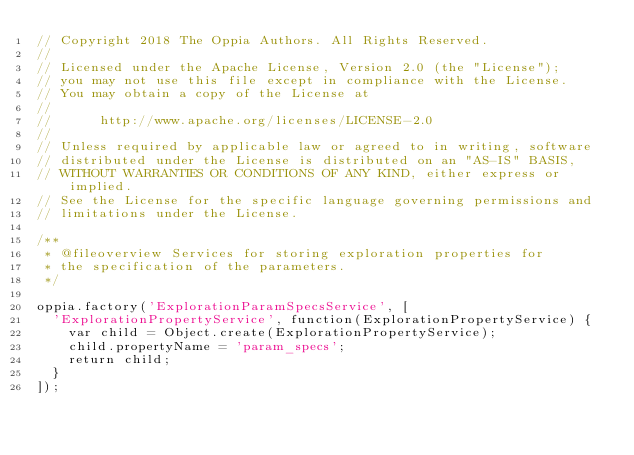Convert code to text. <code><loc_0><loc_0><loc_500><loc_500><_JavaScript_>// Copyright 2018 The Oppia Authors. All Rights Reserved.
//
// Licensed under the Apache License, Version 2.0 (the "License");
// you may not use this file except in compliance with the License.
// You may obtain a copy of the License at
//
//      http://www.apache.org/licenses/LICENSE-2.0
//
// Unless required by applicable law or agreed to in writing, software
// distributed under the License is distributed on an "AS-IS" BASIS,
// WITHOUT WARRANTIES OR CONDITIONS OF ANY KIND, either express or implied.
// See the License for the specific language governing permissions and
// limitations under the License.

/**
 * @fileoverview Services for storing exploration properties for
 * the specification of the parameters.
 */

oppia.factory('ExplorationParamSpecsService', [
  'ExplorationPropertyService', function(ExplorationPropertyService) {
    var child = Object.create(ExplorationPropertyService);
    child.propertyName = 'param_specs';
    return child;
  }
]);
</code> 